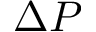Convert formula to latex. <formula><loc_0><loc_0><loc_500><loc_500>\Delta P</formula> 